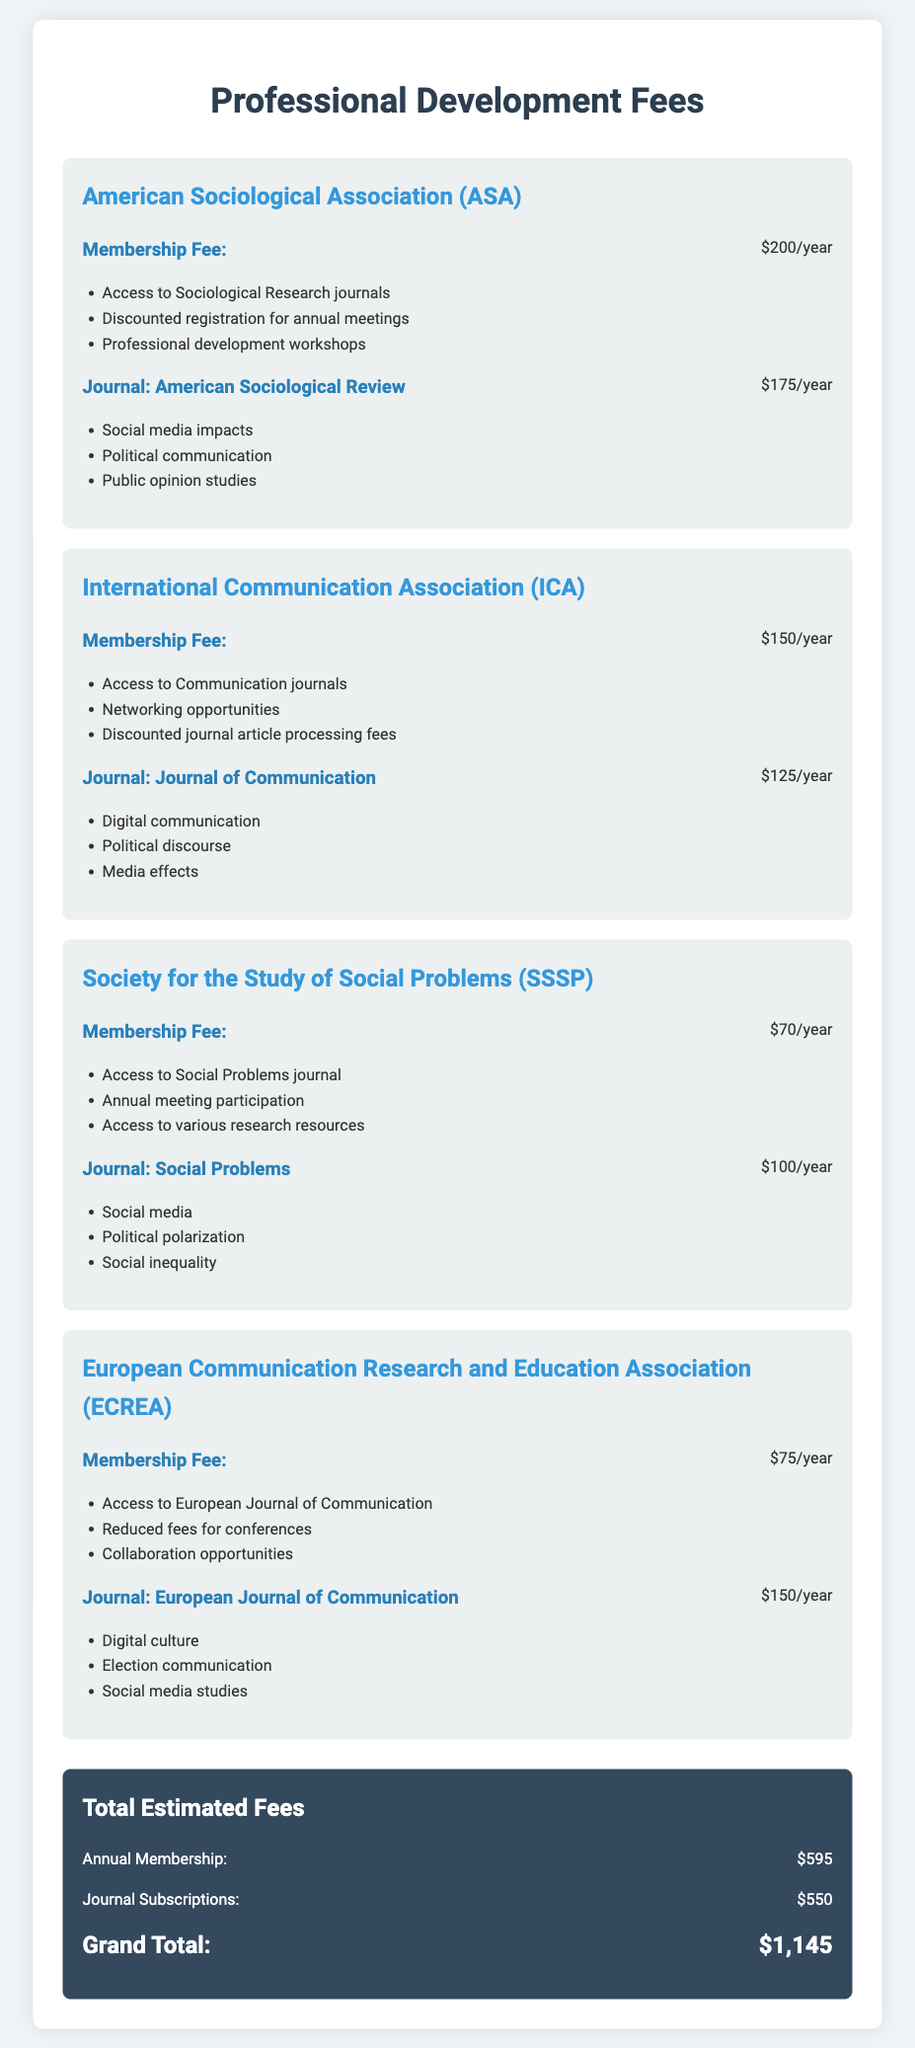What is the membership fee for the American Sociological Association? The membership fee for the American Sociological Association is specified in the document as $200/year.
Answer: $200/year What is the total estimated fee for journal subscriptions? The total estimated fee for journal subscriptions is given in the document, which sums all journal subscription fees to $550.
Answer: $550 Which journal is associated with the International Communication Association? The document mentions that the journal associated with the International Communication Association is the Journal of Communication.
Answer: Journal of Communication How much does it cost to subscribe to the Social Problems journal? The cost for subscribing to the Social Problems journal is provided in the document as $100/year.
Answer: $100/year What topics does the European Journal of Communication cover? According to the document, the topics covered by the European Journal of Communication include digital culture, election communication, and social media studies.
Answer: Digital culture, election communication, social media studies What is the grand total of all fees combined? The grand total of all fees is calculated in the document as $1,145.
Answer: $1,145 Which association has the lowest annual membership fee? The Society for the Study of Social Problems has the lowest membership fee mentioned in the document at $70/year.
Answer: $70/year What types of resources does the membership in the Society for the Study of Social Problems grant access to? The document lists access to the Social Problems journal, annual meeting participation, and various research resources as resources granted by membership.
Answer: Access to Social Problems journal, annual meeting participation, various research resources What is a benefit of joining the International Communication Association? The document states that a benefit of joining the International Communication Association includes networking opportunities.
Answer: Networking opportunities 